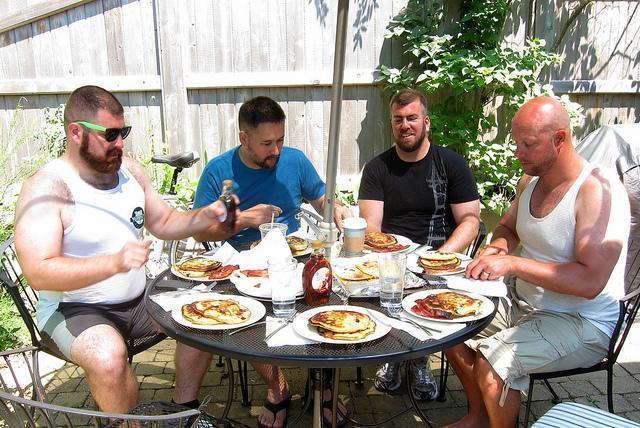What food on the table has the highest level of fat?
Indicate the correct choice and explain in the format: 'Answer: answer
Rationale: rationale.'
Options: Bacon, syrup, pancake, egg. Answer: bacon.
Rationale: The men are eating bacon which is a fatty part of a pig. 